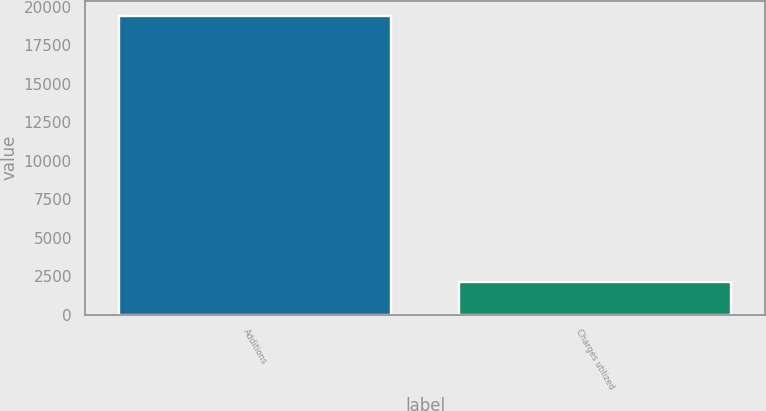<chart> <loc_0><loc_0><loc_500><loc_500><bar_chart><fcel>Additions<fcel>Charges utilized<nl><fcel>19408<fcel>2125<nl></chart> 